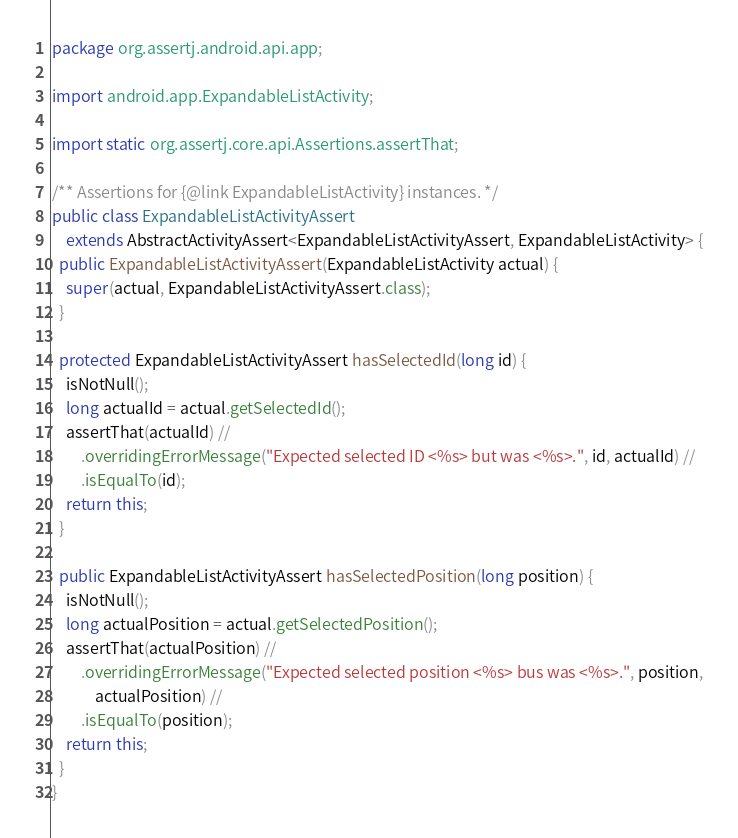Convert code to text. <code><loc_0><loc_0><loc_500><loc_500><_Java_>package org.assertj.android.api.app;

import android.app.ExpandableListActivity;

import static org.assertj.core.api.Assertions.assertThat;

/** Assertions for {@link ExpandableListActivity} instances. */
public class ExpandableListActivityAssert
    extends AbstractActivityAssert<ExpandableListActivityAssert, ExpandableListActivity> {
  public ExpandableListActivityAssert(ExpandableListActivity actual) {
    super(actual, ExpandableListActivityAssert.class);
  }

  protected ExpandableListActivityAssert hasSelectedId(long id) {
    isNotNull();
    long actualId = actual.getSelectedId();
    assertThat(actualId) //
        .overridingErrorMessage("Expected selected ID <%s> but was <%s>.", id, actualId) //
        .isEqualTo(id);
    return this;
  }

  public ExpandableListActivityAssert hasSelectedPosition(long position) {
    isNotNull();
    long actualPosition = actual.getSelectedPosition();
    assertThat(actualPosition) //
        .overridingErrorMessage("Expected selected position <%s> bus was <%s>.", position,
            actualPosition) //
        .isEqualTo(position);
    return this;
  }
}
</code> 